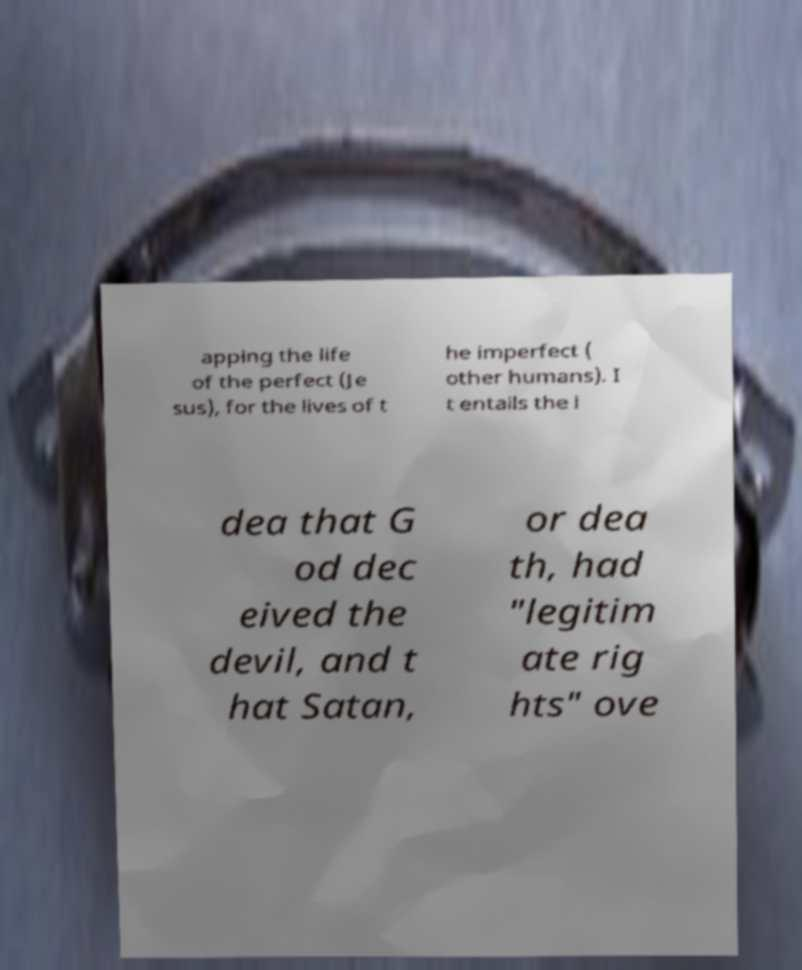Please identify and transcribe the text found in this image. apping the life of the perfect (Je sus), for the lives of t he imperfect ( other humans). I t entails the i dea that G od dec eived the devil, and t hat Satan, or dea th, had "legitim ate rig hts" ove 